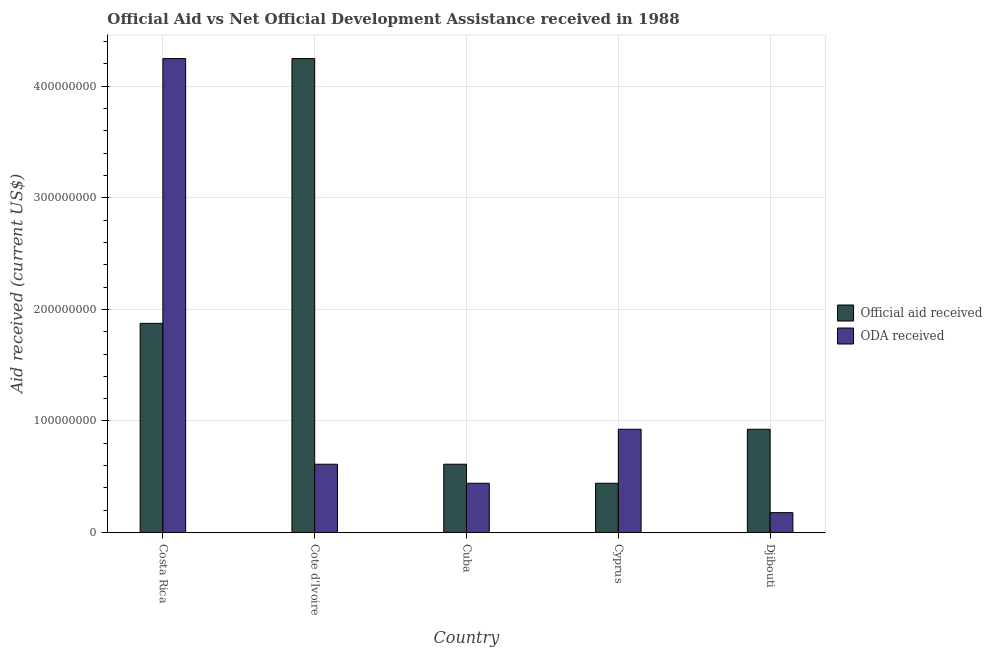How many groups of bars are there?
Give a very brief answer. 5. Are the number of bars per tick equal to the number of legend labels?
Provide a succinct answer. Yes. Are the number of bars on each tick of the X-axis equal?
Provide a short and direct response. Yes. What is the label of the 5th group of bars from the left?
Make the answer very short. Djibouti. In how many cases, is the number of bars for a given country not equal to the number of legend labels?
Provide a short and direct response. 0. What is the oda received in Costa Rica?
Offer a terse response. 4.25e+08. Across all countries, what is the maximum official aid received?
Give a very brief answer. 4.25e+08. Across all countries, what is the minimum oda received?
Ensure brevity in your answer.  1.79e+07. In which country was the official aid received maximum?
Offer a very short reply. Cote d'Ivoire. In which country was the oda received minimum?
Offer a very short reply. Djibouti. What is the total official aid received in the graph?
Make the answer very short. 8.10e+08. What is the difference between the oda received in Cote d'Ivoire and that in Djibouti?
Provide a succinct answer. 4.34e+07. What is the difference between the oda received in Costa Rica and the official aid received in Cote d'Ivoire?
Your answer should be very brief. 0. What is the average official aid received per country?
Your answer should be compact. 1.62e+08. What is the difference between the oda received and official aid received in Cuba?
Give a very brief answer. -1.70e+07. In how many countries, is the official aid received greater than 420000000 US$?
Offer a very short reply. 1. What is the ratio of the oda received in Cote d'Ivoire to that in Cyprus?
Your answer should be very brief. 0.66. Is the oda received in Cyprus less than that in Djibouti?
Provide a short and direct response. No. What is the difference between the highest and the second highest oda received?
Offer a terse response. 3.32e+08. What is the difference between the highest and the lowest official aid received?
Your response must be concise. 3.81e+08. What does the 1st bar from the left in Cuba represents?
Your answer should be compact. Official aid received. What does the 1st bar from the right in Djibouti represents?
Provide a succinct answer. ODA received. Are all the bars in the graph horizontal?
Keep it short and to the point. No. Does the graph contain any zero values?
Keep it short and to the point. No. Where does the legend appear in the graph?
Give a very brief answer. Center right. How many legend labels are there?
Ensure brevity in your answer.  2. What is the title of the graph?
Provide a succinct answer. Official Aid vs Net Official Development Assistance received in 1988 . What is the label or title of the Y-axis?
Your response must be concise. Aid received (current US$). What is the Aid received (current US$) in Official aid received in Costa Rica?
Give a very brief answer. 1.88e+08. What is the Aid received (current US$) in ODA received in Costa Rica?
Keep it short and to the point. 4.25e+08. What is the Aid received (current US$) in Official aid received in Cote d'Ivoire?
Offer a very short reply. 4.25e+08. What is the Aid received (current US$) in ODA received in Cote d'Ivoire?
Provide a succinct answer. 6.13e+07. What is the Aid received (current US$) in Official aid received in Cuba?
Keep it short and to the point. 6.13e+07. What is the Aid received (current US$) of ODA received in Cuba?
Keep it short and to the point. 4.42e+07. What is the Aid received (current US$) in Official aid received in Cyprus?
Your answer should be compact. 4.42e+07. What is the Aid received (current US$) in ODA received in Cyprus?
Provide a succinct answer. 9.26e+07. What is the Aid received (current US$) of Official aid received in Djibouti?
Your answer should be compact. 9.26e+07. What is the Aid received (current US$) in ODA received in Djibouti?
Make the answer very short. 1.79e+07. Across all countries, what is the maximum Aid received (current US$) in Official aid received?
Ensure brevity in your answer.  4.25e+08. Across all countries, what is the maximum Aid received (current US$) in ODA received?
Give a very brief answer. 4.25e+08. Across all countries, what is the minimum Aid received (current US$) in Official aid received?
Your response must be concise. 4.42e+07. Across all countries, what is the minimum Aid received (current US$) in ODA received?
Ensure brevity in your answer.  1.79e+07. What is the total Aid received (current US$) in Official aid received in the graph?
Offer a terse response. 8.10e+08. What is the total Aid received (current US$) of ODA received in the graph?
Offer a very short reply. 6.41e+08. What is the difference between the Aid received (current US$) of Official aid received in Costa Rica and that in Cote d'Ivoire?
Your answer should be compact. -2.37e+08. What is the difference between the Aid received (current US$) of ODA received in Costa Rica and that in Cote d'Ivoire?
Keep it short and to the point. 3.63e+08. What is the difference between the Aid received (current US$) of Official aid received in Costa Rica and that in Cuba?
Your answer should be very brief. 1.26e+08. What is the difference between the Aid received (current US$) of ODA received in Costa Rica and that in Cuba?
Provide a short and direct response. 3.81e+08. What is the difference between the Aid received (current US$) of Official aid received in Costa Rica and that in Cyprus?
Offer a very short reply. 1.43e+08. What is the difference between the Aid received (current US$) of ODA received in Costa Rica and that in Cyprus?
Provide a short and direct response. 3.32e+08. What is the difference between the Aid received (current US$) of Official aid received in Costa Rica and that in Djibouti?
Provide a short and direct response. 9.49e+07. What is the difference between the Aid received (current US$) in ODA received in Costa Rica and that in Djibouti?
Offer a terse response. 4.07e+08. What is the difference between the Aid received (current US$) of Official aid received in Cote d'Ivoire and that in Cuba?
Ensure brevity in your answer.  3.63e+08. What is the difference between the Aid received (current US$) in ODA received in Cote d'Ivoire and that in Cuba?
Provide a succinct answer. 1.70e+07. What is the difference between the Aid received (current US$) of Official aid received in Cote d'Ivoire and that in Cyprus?
Provide a short and direct response. 3.81e+08. What is the difference between the Aid received (current US$) in ODA received in Cote d'Ivoire and that in Cyprus?
Make the answer very short. -3.13e+07. What is the difference between the Aid received (current US$) in Official aid received in Cote d'Ivoire and that in Djibouti?
Your answer should be very brief. 3.32e+08. What is the difference between the Aid received (current US$) of ODA received in Cote d'Ivoire and that in Djibouti?
Offer a terse response. 4.34e+07. What is the difference between the Aid received (current US$) in Official aid received in Cuba and that in Cyprus?
Your answer should be very brief. 1.70e+07. What is the difference between the Aid received (current US$) of ODA received in Cuba and that in Cyprus?
Make the answer very short. -4.84e+07. What is the difference between the Aid received (current US$) in Official aid received in Cuba and that in Djibouti?
Offer a very short reply. -3.13e+07. What is the difference between the Aid received (current US$) in ODA received in Cuba and that in Djibouti?
Your answer should be very brief. 2.63e+07. What is the difference between the Aid received (current US$) of Official aid received in Cyprus and that in Djibouti?
Give a very brief answer. -4.84e+07. What is the difference between the Aid received (current US$) in ODA received in Cyprus and that in Djibouti?
Give a very brief answer. 7.47e+07. What is the difference between the Aid received (current US$) of Official aid received in Costa Rica and the Aid received (current US$) of ODA received in Cote d'Ivoire?
Your answer should be very brief. 1.26e+08. What is the difference between the Aid received (current US$) of Official aid received in Costa Rica and the Aid received (current US$) of ODA received in Cuba?
Your answer should be compact. 1.43e+08. What is the difference between the Aid received (current US$) in Official aid received in Costa Rica and the Aid received (current US$) in ODA received in Cyprus?
Give a very brief answer. 9.49e+07. What is the difference between the Aid received (current US$) in Official aid received in Costa Rica and the Aid received (current US$) in ODA received in Djibouti?
Provide a short and direct response. 1.70e+08. What is the difference between the Aid received (current US$) of Official aid received in Cote d'Ivoire and the Aid received (current US$) of ODA received in Cuba?
Make the answer very short. 3.81e+08. What is the difference between the Aid received (current US$) of Official aid received in Cote d'Ivoire and the Aid received (current US$) of ODA received in Cyprus?
Your answer should be compact. 3.32e+08. What is the difference between the Aid received (current US$) in Official aid received in Cote d'Ivoire and the Aid received (current US$) in ODA received in Djibouti?
Provide a short and direct response. 4.07e+08. What is the difference between the Aid received (current US$) of Official aid received in Cuba and the Aid received (current US$) of ODA received in Cyprus?
Offer a terse response. -3.13e+07. What is the difference between the Aid received (current US$) of Official aid received in Cuba and the Aid received (current US$) of ODA received in Djibouti?
Your answer should be compact. 4.34e+07. What is the difference between the Aid received (current US$) of Official aid received in Cyprus and the Aid received (current US$) of ODA received in Djibouti?
Give a very brief answer. 2.63e+07. What is the average Aid received (current US$) in Official aid received per country?
Your answer should be compact. 1.62e+08. What is the average Aid received (current US$) in ODA received per country?
Make the answer very short. 1.28e+08. What is the difference between the Aid received (current US$) of Official aid received and Aid received (current US$) of ODA received in Costa Rica?
Provide a short and direct response. -2.37e+08. What is the difference between the Aid received (current US$) in Official aid received and Aid received (current US$) in ODA received in Cote d'Ivoire?
Give a very brief answer. 3.63e+08. What is the difference between the Aid received (current US$) of Official aid received and Aid received (current US$) of ODA received in Cuba?
Make the answer very short. 1.70e+07. What is the difference between the Aid received (current US$) of Official aid received and Aid received (current US$) of ODA received in Cyprus?
Provide a short and direct response. -4.84e+07. What is the difference between the Aid received (current US$) in Official aid received and Aid received (current US$) in ODA received in Djibouti?
Offer a terse response. 7.47e+07. What is the ratio of the Aid received (current US$) of Official aid received in Costa Rica to that in Cote d'Ivoire?
Offer a very short reply. 0.44. What is the ratio of the Aid received (current US$) of ODA received in Costa Rica to that in Cote d'Ivoire?
Offer a terse response. 6.93. What is the ratio of the Aid received (current US$) in Official aid received in Costa Rica to that in Cuba?
Give a very brief answer. 3.06. What is the ratio of the Aid received (current US$) of ODA received in Costa Rica to that in Cuba?
Your answer should be very brief. 9.61. What is the ratio of the Aid received (current US$) in Official aid received in Costa Rica to that in Cyprus?
Provide a short and direct response. 4.24. What is the ratio of the Aid received (current US$) in ODA received in Costa Rica to that in Cyprus?
Offer a very short reply. 4.59. What is the ratio of the Aid received (current US$) of Official aid received in Costa Rica to that in Djibouti?
Provide a succinct answer. 2.02. What is the ratio of the Aid received (current US$) in ODA received in Costa Rica to that in Djibouti?
Ensure brevity in your answer.  23.75. What is the ratio of the Aid received (current US$) of Official aid received in Cote d'Ivoire to that in Cuba?
Keep it short and to the point. 6.93. What is the ratio of the Aid received (current US$) in ODA received in Cote d'Ivoire to that in Cuba?
Make the answer very short. 1.39. What is the ratio of the Aid received (current US$) of Official aid received in Cote d'Ivoire to that in Cyprus?
Keep it short and to the point. 9.61. What is the ratio of the Aid received (current US$) in ODA received in Cote d'Ivoire to that in Cyprus?
Offer a terse response. 0.66. What is the ratio of the Aid received (current US$) in Official aid received in Cote d'Ivoire to that in Djibouti?
Your answer should be compact. 4.59. What is the ratio of the Aid received (current US$) of ODA received in Cote d'Ivoire to that in Djibouti?
Give a very brief answer. 3.43. What is the ratio of the Aid received (current US$) of Official aid received in Cuba to that in Cyprus?
Ensure brevity in your answer.  1.39. What is the ratio of the Aid received (current US$) of ODA received in Cuba to that in Cyprus?
Your answer should be compact. 0.48. What is the ratio of the Aid received (current US$) in Official aid received in Cuba to that in Djibouti?
Your answer should be very brief. 0.66. What is the ratio of the Aid received (current US$) in ODA received in Cuba to that in Djibouti?
Offer a very short reply. 2.47. What is the ratio of the Aid received (current US$) in Official aid received in Cyprus to that in Djibouti?
Provide a succinct answer. 0.48. What is the ratio of the Aid received (current US$) of ODA received in Cyprus to that in Djibouti?
Ensure brevity in your answer.  5.18. What is the difference between the highest and the second highest Aid received (current US$) of Official aid received?
Provide a short and direct response. 2.37e+08. What is the difference between the highest and the second highest Aid received (current US$) of ODA received?
Make the answer very short. 3.32e+08. What is the difference between the highest and the lowest Aid received (current US$) in Official aid received?
Make the answer very short. 3.81e+08. What is the difference between the highest and the lowest Aid received (current US$) in ODA received?
Offer a terse response. 4.07e+08. 